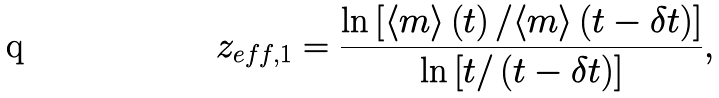Convert formula to latex. <formula><loc_0><loc_0><loc_500><loc_500>z _ { e f f , 1 } = \frac { \ln { \left [ \langle m \rangle \left ( t \right ) / \langle m \rangle \left ( t - \delta t \right ) \right ] } } { \ln { \left [ t / \left ( t - \delta t \right ) \right ] } } ,</formula> 